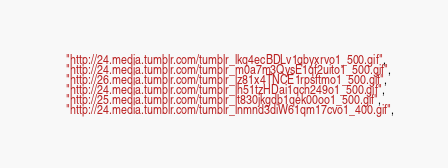Convert code to text. <code><loc_0><loc_0><loc_500><loc_500><_Python_>    "http://24.media.tumblr.com/tumblr_lkq4ecBDLv1qbyxrvo1_500.gif",
    "http://24.media.tumblr.com/tumblr_m0a7m3QysE1qf2uito1_500.gif",
    "http://26.media.tumblr.com/tumblr_lz81x4TNCE1rpsftmo1_500.gif",
    "http://24.media.tumblr.com/tumblr_lh51tzHDai1qcn249o1_500.gif",
    "http://25.media.tumblr.com/tumblr_lt830jkgdb1qek00oo1_500.gif",
    "http://24.media.tumblr.com/tumblr_lnmnd3diW61qm17cvo1_400.gif",</code> 